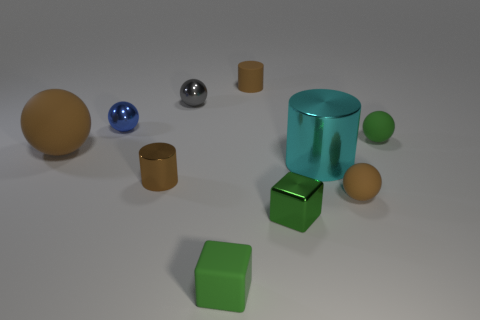Subtract all purple balls. Subtract all purple blocks. How many balls are left? 5 Subtract all blocks. How many objects are left? 8 Subtract 0 yellow cubes. How many objects are left? 10 Subtract all big cyan metallic objects. Subtract all tiny brown objects. How many objects are left? 6 Add 8 green metallic blocks. How many green metallic blocks are left? 9 Add 5 tiny blue rubber objects. How many tiny blue rubber objects exist? 5 